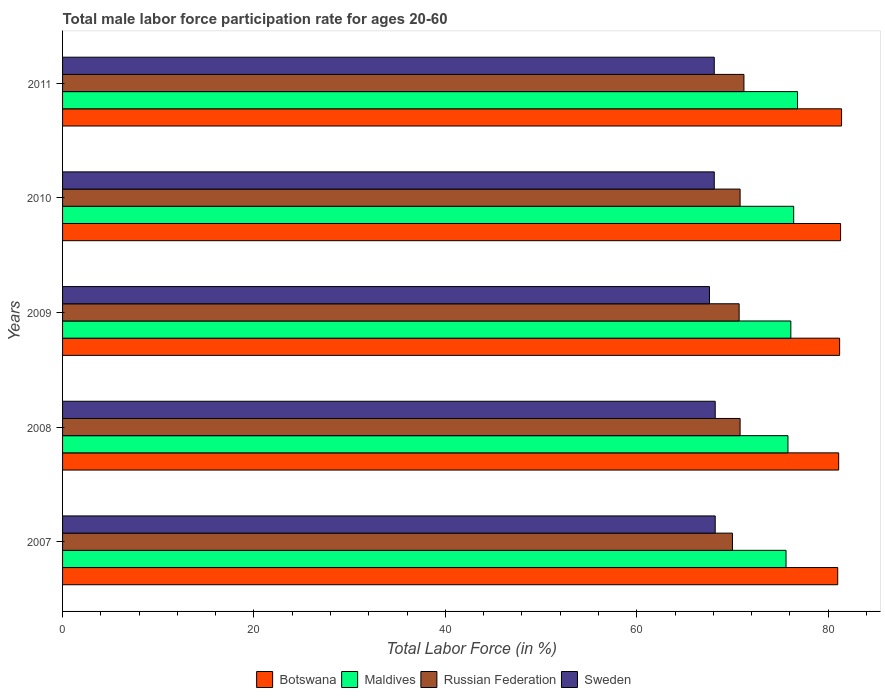How many groups of bars are there?
Your response must be concise. 5. How many bars are there on the 3rd tick from the top?
Provide a succinct answer. 4. What is the male labor force participation rate in Sweden in 2009?
Keep it short and to the point. 67.6. Across all years, what is the maximum male labor force participation rate in Russian Federation?
Give a very brief answer. 71.2. Across all years, what is the minimum male labor force participation rate in Botswana?
Keep it short and to the point. 81. In which year was the male labor force participation rate in Botswana maximum?
Provide a short and direct response. 2011. In which year was the male labor force participation rate in Botswana minimum?
Your answer should be compact. 2007. What is the total male labor force participation rate in Botswana in the graph?
Provide a succinct answer. 406. What is the difference between the male labor force participation rate in Botswana in 2008 and that in 2010?
Ensure brevity in your answer.  -0.2. What is the difference between the male labor force participation rate in Russian Federation in 2010 and the male labor force participation rate in Botswana in 2007?
Your response must be concise. -10.2. What is the average male labor force participation rate in Sweden per year?
Provide a short and direct response. 68.04. In the year 2009, what is the difference between the male labor force participation rate in Sweden and male labor force participation rate in Botswana?
Give a very brief answer. -13.6. In how many years, is the male labor force participation rate in Maldives greater than 8 %?
Your answer should be compact. 5. What is the ratio of the male labor force participation rate in Botswana in 2007 to that in 2011?
Offer a terse response. 1. Is the male labor force participation rate in Botswana in 2010 less than that in 2011?
Give a very brief answer. Yes. What is the difference between the highest and the second highest male labor force participation rate in Maldives?
Give a very brief answer. 0.4. What is the difference between the highest and the lowest male labor force participation rate in Sweden?
Ensure brevity in your answer.  0.6. Is the sum of the male labor force participation rate in Maldives in 2007 and 2009 greater than the maximum male labor force participation rate in Russian Federation across all years?
Your answer should be very brief. Yes. Is it the case that in every year, the sum of the male labor force participation rate in Sweden and male labor force participation rate in Botswana is greater than the sum of male labor force participation rate in Maldives and male labor force participation rate in Russian Federation?
Offer a terse response. No. What does the 3rd bar from the bottom in 2007 represents?
Your response must be concise. Russian Federation. Is it the case that in every year, the sum of the male labor force participation rate in Russian Federation and male labor force participation rate in Sweden is greater than the male labor force participation rate in Botswana?
Ensure brevity in your answer.  Yes. Are the values on the major ticks of X-axis written in scientific E-notation?
Ensure brevity in your answer.  No. Does the graph contain any zero values?
Offer a terse response. No. Where does the legend appear in the graph?
Keep it short and to the point. Bottom center. How are the legend labels stacked?
Your answer should be compact. Horizontal. What is the title of the graph?
Keep it short and to the point. Total male labor force participation rate for ages 20-60. Does "Congo (Democratic)" appear as one of the legend labels in the graph?
Your answer should be compact. No. What is the label or title of the X-axis?
Your answer should be compact. Total Labor Force (in %). What is the Total Labor Force (in %) in Maldives in 2007?
Keep it short and to the point. 75.6. What is the Total Labor Force (in %) of Sweden in 2007?
Keep it short and to the point. 68.2. What is the Total Labor Force (in %) of Botswana in 2008?
Make the answer very short. 81.1. What is the Total Labor Force (in %) of Maldives in 2008?
Offer a very short reply. 75.8. What is the Total Labor Force (in %) in Russian Federation in 2008?
Ensure brevity in your answer.  70.8. What is the Total Labor Force (in %) in Sweden in 2008?
Your answer should be compact. 68.2. What is the Total Labor Force (in %) of Botswana in 2009?
Give a very brief answer. 81.2. What is the Total Labor Force (in %) in Maldives in 2009?
Give a very brief answer. 76.1. What is the Total Labor Force (in %) in Russian Federation in 2009?
Your response must be concise. 70.7. What is the Total Labor Force (in %) in Sweden in 2009?
Offer a very short reply. 67.6. What is the Total Labor Force (in %) in Botswana in 2010?
Offer a terse response. 81.3. What is the Total Labor Force (in %) of Maldives in 2010?
Offer a terse response. 76.4. What is the Total Labor Force (in %) of Russian Federation in 2010?
Provide a succinct answer. 70.8. What is the Total Labor Force (in %) of Sweden in 2010?
Give a very brief answer. 68.1. What is the Total Labor Force (in %) in Botswana in 2011?
Your answer should be compact. 81.4. What is the Total Labor Force (in %) of Maldives in 2011?
Offer a terse response. 76.8. What is the Total Labor Force (in %) in Russian Federation in 2011?
Keep it short and to the point. 71.2. What is the Total Labor Force (in %) of Sweden in 2011?
Give a very brief answer. 68.1. Across all years, what is the maximum Total Labor Force (in %) in Botswana?
Offer a terse response. 81.4. Across all years, what is the maximum Total Labor Force (in %) in Maldives?
Your answer should be compact. 76.8. Across all years, what is the maximum Total Labor Force (in %) in Russian Federation?
Make the answer very short. 71.2. Across all years, what is the maximum Total Labor Force (in %) of Sweden?
Make the answer very short. 68.2. Across all years, what is the minimum Total Labor Force (in %) of Maldives?
Give a very brief answer. 75.6. Across all years, what is the minimum Total Labor Force (in %) in Russian Federation?
Offer a terse response. 70. Across all years, what is the minimum Total Labor Force (in %) in Sweden?
Provide a succinct answer. 67.6. What is the total Total Labor Force (in %) of Botswana in the graph?
Keep it short and to the point. 406. What is the total Total Labor Force (in %) in Maldives in the graph?
Offer a terse response. 380.7. What is the total Total Labor Force (in %) of Russian Federation in the graph?
Offer a very short reply. 353.5. What is the total Total Labor Force (in %) in Sweden in the graph?
Make the answer very short. 340.2. What is the difference between the Total Labor Force (in %) of Botswana in 2007 and that in 2008?
Ensure brevity in your answer.  -0.1. What is the difference between the Total Labor Force (in %) in Sweden in 2007 and that in 2008?
Your answer should be very brief. 0. What is the difference between the Total Labor Force (in %) of Botswana in 2007 and that in 2009?
Your answer should be very brief. -0.2. What is the difference between the Total Labor Force (in %) of Maldives in 2007 and that in 2009?
Ensure brevity in your answer.  -0.5. What is the difference between the Total Labor Force (in %) in Botswana in 2007 and that in 2010?
Make the answer very short. -0.3. What is the difference between the Total Labor Force (in %) of Sweden in 2007 and that in 2010?
Provide a short and direct response. 0.1. What is the difference between the Total Labor Force (in %) of Botswana in 2007 and that in 2011?
Ensure brevity in your answer.  -0.4. What is the difference between the Total Labor Force (in %) in Maldives in 2007 and that in 2011?
Provide a succinct answer. -1.2. What is the difference between the Total Labor Force (in %) in Russian Federation in 2007 and that in 2011?
Your response must be concise. -1.2. What is the difference between the Total Labor Force (in %) of Maldives in 2008 and that in 2009?
Offer a terse response. -0.3. What is the difference between the Total Labor Force (in %) in Russian Federation in 2008 and that in 2009?
Your answer should be very brief. 0.1. What is the difference between the Total Labor Force (in %) of Russian Federation in 2008 and that in 2011?
Your answer should be very brief. -0.4. What is the difference between the Total Labor Force (in %) in Sweden in 2008 and that in 2011?
Ensure brevity in your answer.  0.1. What is the difference between the Total Labor Force (in %) in Botswana in 2009 and that in 2010?
Provide a short and direct response. -0.1. What is the difference between the Total Labor Force (in %) of Russian Federation in 2009 and that in 2010?
Ensure brevity in your answer.  -0.1. What is the difference between the Total Labor Force (in %) of Sweden in 2009 and that in 2010?
Offer a terse response. -0.5. What is the difference between the Total Labor Force (in %) of Botswana in 2009 and that in 2011?
Provide a succinct answer. -0.2. What is the difference between the Total Labor Force (in %) in Russian Federation in 2009 and that in 2011?
Make the answer very short. -0.5. What is the difference between the Total Labor Force (in %) of Botswana in 2010 and that in 2011?
Give a very brief answer. -0.1. What is the difference between the Total Labor Force (in %) in Maldives in 2010 and that in 2011?
Your response must be concise. -0.4. What is the difference between the Total Labor Force (in %) of Russian Federation in 2010 and that in 2011?
Your answer should be very brief. -0.4. What is the difference between the Total Labor Force (in %) of Sweden in 2010 and that in 2011?
Keep it short and to the point. 0. What is the difference between the Total Labor Force (in %) of Botswana in 2007 and the Total Labor Force (in %) of Maldives in 2008?
Offer a terse response. 5.2. What is the difference between the Total Labor Force (in %) in Botswana in 2007 and the Total Labor Force (in %) in Sweden in 2008?
Give a very brief answer. 12.8. What is the difference between the Total Labor Force (in %) of Maldives in 2007 and the Total Labor Force (in %) of Russian Federation in 2008?
Provide a succinct answer. 4.8. What is the difference between the Total Labor Force (in %) in Russian Federation in 2007 and the Total Labor Force (in %) in Sweden in 2008?
Your answer should be very brief. 1.8. What is the difference between the Total Labor Force (in %) of Botswana in 2007 and the Total Labor Force (in %) of Russian Federation in 2009?
Provide a succinct answer. 10.3. What is the difference between the Total Labor Force (in %) in Maldives in 2007 and the Total Labor Force (in %) in Sweden in 2009?
Offer a terse response. 8. What is the difference between the Total Labor Force (in %) in Botswana in 2007 and the Total Labor Force (in %) in Maldives in 2011?
Provide a succinct answer. 4.2. What is the difference between the Total Labor Force (in %) in Botswana in 2007 and the Total Labor Force (in %) in Sweden in 2011?
Provide a short and direct response. 12.9. What is the difference between the Total Labor Force (in %) of Botswana in 2008 and the Total Labor Force (in %) of Russian Federation in 2009?
Offer a terse response. 10.4. What is the difference between the Total Labor Force (in %) of Botswana in 2008 and the Total Labor Force (in %) of Sweden in 2009?
Keep it short and to the point. 13.5. What is the difference between the Total Labor Force (in %) in Maldives in 2008 and the Total Labor Force (in %) in Russian Federation in 2009?
Make the answer very short. 5.1. What is the difference between the Total Labor Force (in %) in Maldives in 2008 and the Total Labor Force (in %) in Sweden in 2009?
Make the answer very short. 8.2. What is the difference between the Total Labor Force (in %) of Botswana in 2008 and the Total Labor Force (in %) of Maldives in 2010?
Ensure brevity in your answer.  4.7. What is the difference between the Total Labor Force (in %) in Maldives in 2008 and the Total Labor Force (in %) in Russian Federation in 2010?
Offer a very short reply. 5. What is the difference between the Total Labor Force (in %) of Botswana in 2008 and the Total Labor Force (in %) of Russian Federation in 2011?
Your answer should be compact. 9.9. What is the difference between the Total Labor Force (in %) of Maldives in 2008 and the Total Labor Force (in %) of Russian Federation in 2011?
Provide a succinct answer. 4.6. What is the difference between the Total Labor Force (in %) of Botswana in 2009 and the Total Labor Force (in %) of Maldives in 2010?
Provide a succinct answer. 4.8. What is the difference between the Total Labor Force (in %) of Maldives in 2009 and the Total Labor Force (in %) of Russian Federation in 2010?
Give a very brief answer. 5.3. What is the difference between the Total Labor Force (in %) of Maldives in 2009 and the Total Labor Force (in %) of Sweden in 2010?
Your response must be concise. 8. What is the difference between the Total Labor Force (in %) in Botswana in 2009 and the Total Labor Force (in %) in Maldives in 2011?
Keep it short and to the point. 4.4. What is the difference between the Total Labor Force (in %) of Botswana in 2009 and the Total Labor Force (in %) of Russian Federation in 2011?
Give a very brief answer. 10. What is the difference between the Total Labor Force (in %) in Maldives in 2009 and the Total Labor Force (in %) in Russian Federation in 2011?
Your answer should be compact. 4.9. What is the difference between the Total Labor Force (in %) of Maldives in 2009 and the Total Labor Force (in %) of Sweden in 2011?
Your response must be concise. 8. What is the difference between the Total Labor Force (in %) of Botswana in 2010 and the Total Labor Force (in %) of Maldives in 2011?
Make the answer very short. 4.5. What is the difference between the Total Labor Force (in %) of Botswana in 2010 and the Total Labor Force (in %) of Russian Federation in 2011?
Your answer should be compact. 10.1. What is the difference between the Total Labor Force (in %) in Maldives in 2010 and the Total Labor Force (in %) in Sweden in 2011?
Ensure brevity in your answer.  8.3. What is the difference between the Total Labor Force (in %) of Russian Federation in 2010 and the Total Labor Force (in %) of Sweden in 2011?
Ensure brevity in your answer.  2.7. What is the average Total Labor Force (in %) in Botswana per year?
Your answer should be compact. 81.2. What is the average Total Labor Force (in %) of Maldives per year?
Ensure brevity in your answer.  76.14. What is the average Total Labor Force (in %) of Russian Federation per year?
Keep it short and to the point. 70.7. What is the average Total Labor Force (in %) of Sweden per year?
Your answer should be compact. 68.04. In the year 2007, what is the difference between the Total Labor Force (in %) in Botswana and Total Labor Force (in %) in Maldives?
Your response must be concise. 5.4. In the year 2007, what is the difference between the Total Labor Force (in %) in Botswana and Total Labor Force (in %) in Russian Federation?
Your response must be concise. 11. In the year 2007, what is the difference between the Total Labor Force (in %) of Maldives and Total Labor Force (in %) of Russian Federation?
Offer a very short reply. 5.6. In the year 2007, what is the difference between the Total Labor Force (in %) of Maldives and Total Labor Force (in %) of Sweden?
Offer a terse response. 7.4. In the year 2008, what is the difference between the Total Labor Force (in %) in Maldives and Total Labor Force (in %) in Russian Federation?
Offer a very short reply. 5. In the year 2008, what is the difference between the Total Labor Force (in %) of Maldives and Total Labor Force (in %) of Sweden?
Offer a very short reply. 7.6. In the year 2009, what is the difference between the Total Labor Force (in %) of Russian Federation and Total Labor Force (in %) of Sweden?
Ensure brevity in your answer.  3.1. In the year 2010, what is the difference between the Total Labor Force (in %) of Botswana and Total Labor Force (in %) of Russian Federation?
Offer a very short reply. 10.5. In the year 2010, what is the difference between the Total Labor Force (in %) in Botswana and Total Labor Force (in %) in Sweden?
Your answer should be very brief. 13.2. In the year 2010, what is the difference between the Total Labor Force (in %) in Maldives and Total Labor Force (in %) in Sweden?
Provide a succinct answer. 8.3. In the year 2011, what is the difference between the Total Labor Force (in %) of Botswana and Total Labor Force (in %) of Maldives?
Provide a succinct answer. 4.6. In the year 2011, what is the difference between the Total Labor Force (in %) of Botswana and Total Labor Force (in %) of Sweden?
Offer a terse response. 13.3. In the year 2011, what is the difference between the Total Labor Force (in %) in Maldives and Total Labor Force (in %) in Sweden?
Provide a short and direct response. 8.7. What is the ratio of the Total Labor Force (in %) in Maldives in 2007 to that in 2008?
Make the answer very short. 1. What is the ratio of the Total Labor Force (in %) in Russian Federation in 2007 to that in 2008?
Keep it short and to the point. 0.99. What is the ratio of the Total Labor Force (in %) of Sweden in 2007 to that in 2008?
Make the answer very short. 1. What is the ratio of the Total Labor Force (in %) of Maldives in 2007 to that in 2009?
Ensure brevity in your answer.  0.99. What is the ratio of the Total Labor Force (in %) in Sweden in 2007 to that in 2009?
Provide a short and direct response. 1.01. What is the ratio of the Total Labor Force (in %) of Botswana in 2007 to that in 2010?
Keep it short and to the point. 1. What is the ratio of the Total Labor Force (in %) in Maldives in 2007 to that in 2010?
Your answer should be compact. 0.99. What is the ratio of the Total Labor Force (in %) in Russian Federation in 2007 to that in 2010?
Provide a short and direct response. 0.99. What is the ratio of the Total Labor Force (in %) in Sweden in 2007 to that in 2010?
Give a very brief answer. 1. What is the ratio of the Total Labor Force (in %) of Botswana in 2007 to that in 2011?
Offer a very short reply. 1. What is the ratio of the Total Labor Force (in %) of Maldives in 2007 to that in 2011?
Ensure brevity in your answer.  0.98. What is the ratio of the Total Labor Force (in %) in Russian Federation in 2007 to that in 2011?
Your answer should be very brief. 0.98. What is the ratio of the Total Labor Force (in %) in Sweden in 2007 to that in 2011?
Ensure brevity in your answer.  1. What is the ratio of the Total Labor Force (in %) in Russian Federation in 2008 to that in 2009?
Your answer should be very brief. 1. What is the ratio of the Total Labor Force (in %) of Sweden in 2008 to that in 2009?
Keep it short and to the point. 1.01. What is the ratio of the Total Labor Force (in %) of Botswana in 2008 to that in 2010?
Offer a terse response. 1. What is the ratio of the Total Labor Force (in %) of Maldives in 2008 to that in 2010?
Provide a succinct answer. 0.99. What is the ratio of the Total Labor Force (in %) of Russian Federation in 2008 to that in 2010?
Provide a succinct answer. 1. What is the ratio of the Total Labor Force (in %) of Botswana in 2008 to that in 2011?
Provide a short and direct response. 1. What is the ratio of the Total Labor Force (in %) of Maldives in 2008 to that in 2011?
Your response must be concise. 0.99. What is the ratio of the Total Labor Force (in %) of Botswana in 2009 to that in 2010?
Keep it short and to the point. 1. What is the ratio of the Total Labor Force (in %) of Maldives in 2009 to that in 2010?
Provide a succinct answer. 1. What is the ratio of the Total Labor Force (in %) of Sweden in 2009 to that in 2010?
Make the answer very short. 0.99. What is the ratio of the Total Labor Force (in %) of Maldives in 2009 to that in 2011?
Offer a very short reply. 0.99. What is the ratio of the Total Labor Force (in %) in Russian Federation in 2009 to that in 2011?
Your response must be concise. 0.99. What is the ratio of the Total Labor Force (in %) in Botswana in 2010 to that in 2011?
Provide a succinct answer. 1. What is the ratio of the Total Labor Force (in %) in Sweden in 2010 to that in 2011?
Offer a terse response. 1. What is the difference between the highest and the second highest Total Labor Force (in %) in Botswana?
Keep it short and to the point. 0.1. What is the difference between the highest and the second highest Total Labor Force (in %) of Russian Federation?
Provide a succinct answer. 0.4. What is the difference between the highest and the lowest Total Labor Force (in %) in Sweden?
Make the answer very short. 0.6. 